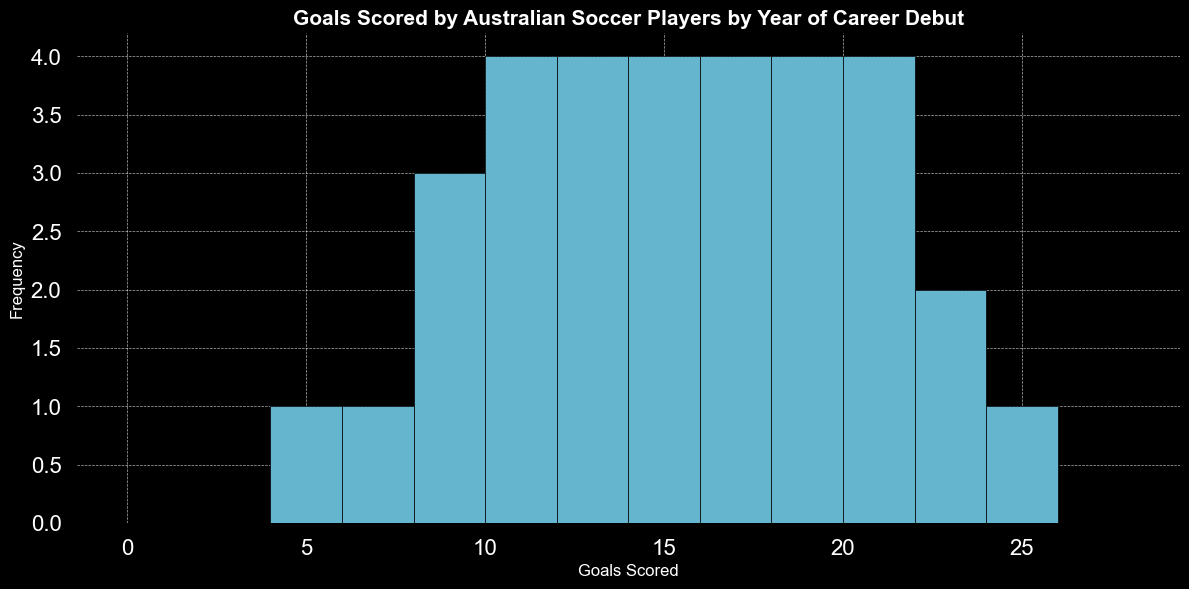What's the most frequent range of goals scored? The histogram shows the frequency of each goals scored range. The range from 10 to 12 goals scored has the highest bar, indicating the peak frequency.
Answer: 10-12 Which year of career debut had the highest number of goals scored? By examining the histogram, we can see the highest bar is at the range 22-24 goals scored. The data shows that players debuting in 2007 scored 24 goals, which is the highest.
Answer: 2007 How many players scored between 20 and 22 goals? The height of the bars in the range 20-22 indicates the number of players. The bars for the range 20-22 show a total of 4 players when summed up.
Answer: 4 Is the number of players who scored less than 10 goals higher or lower than those who scored more than 20 goals? The histogram can be divided into those two ranges. Players scoring less than 10 goals have three bars in the histogram. Add the heights for these bars: 12 and 8. Players scoring more than 20 goals have two bars: 22 and 24. Comparing the sums, 3 < 4.
Answer: Lower What is the total number of players debuting from 1996 to 2000 who scored 10 goals or more? Examine the data for years from 1996 to 2000 and count the players from the histogram bars within the required range. The resulting counts are: 10 in 1996, 11 in 1997, 14 in 1998, 5 in 1999, and 17 in 2000. Only those ≥10 are considered: 10 + 11 + 14 + 17 = a total of 4 players.
Answer: 4 What's the median range of goals scored by debuting players? To find the median, we sort the total range of goal counts (from the histogram) and find the middle value or range. The range of goals scored aligns mostly within consistent midpoints from 11 to 14 goals scored, given the evenly distributed frequencies.
Answer: 11-13 How does the frequency of players scoring exactly 13 goals compare to those scoring exactly 8 goals? Compare the height of bars at the exact values of goals scored (13 and 8). The bar for 13 goals is higher than the one for 8 goals.
Answer: 13 goals is higher Within what range do most of the players' goal totals fall? Observing the histogram, the densest cluster of bars is between 10 and 20 goals scored.
Answer: 10-20 What range appears to have identical frequencies? Look for adjacent bars with the same height. Between 10-12 and 13-15, there are bars with identical frequency.
Answer: 10-12 & 13-15 